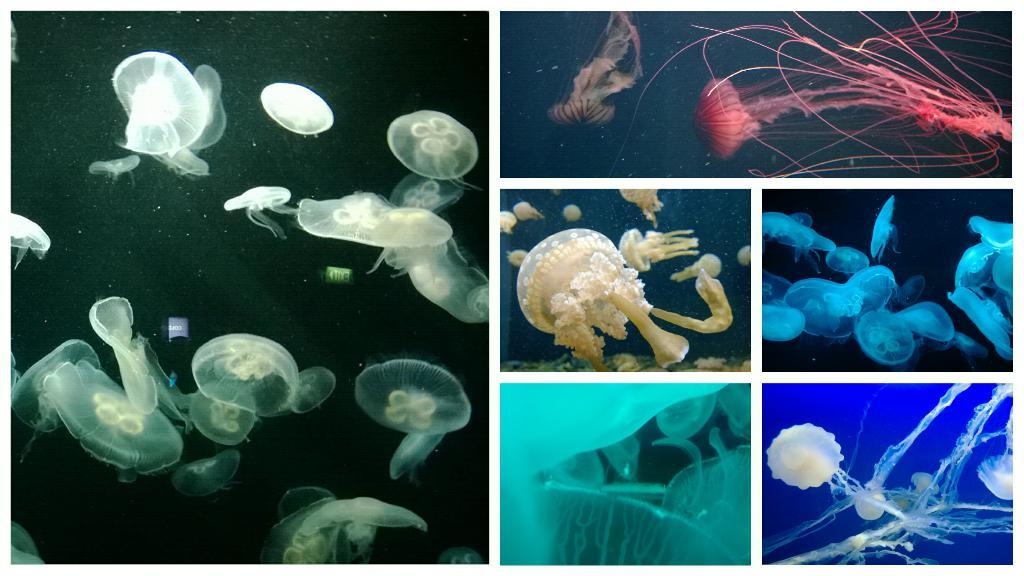What type of artwork is depicted in the image? The image is a collage. What creatures can be seen in the collage? There are jellyfishes in the image. What type of butter is spread on the pizzas in the image? There are no pizzas or butter present in the image; it features a collage with jellyfishes. 